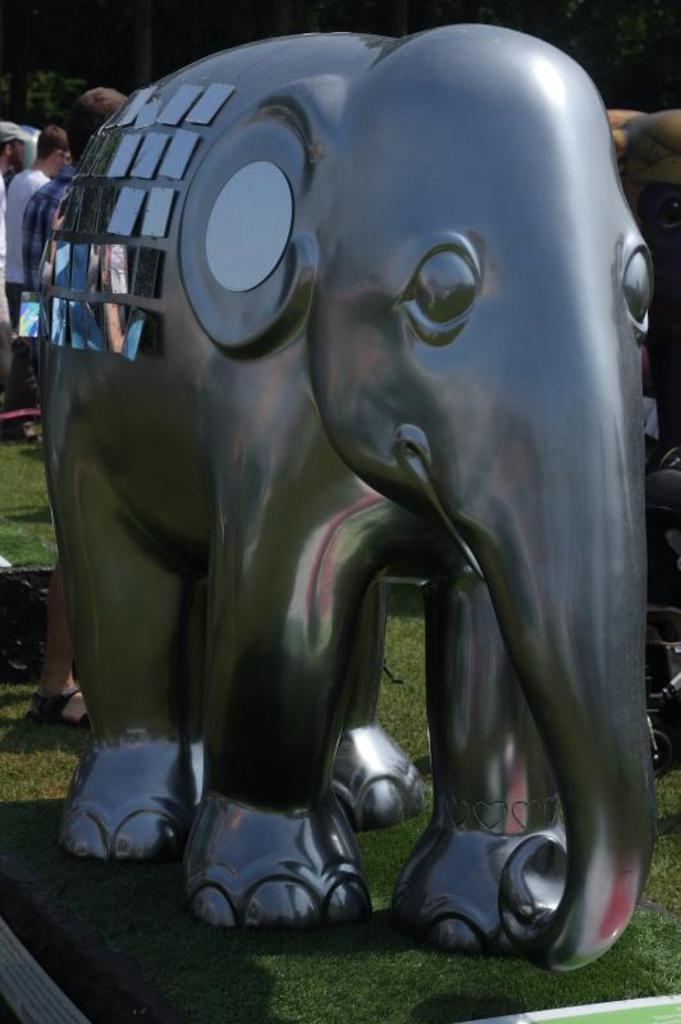What type of toy is present in the image? There is a toy elephant in the image. What can be seen in the background of the image? There are people standing in the background of the image. What color are the trees in the image? The trees in the image have green color. What letter is written on the toy elephant in the image? There is no letter written on the toy elephant in the image. What type of frame surrounds the image? There is no frame surrounding the image; it is a photograph or digital image without a frame. 